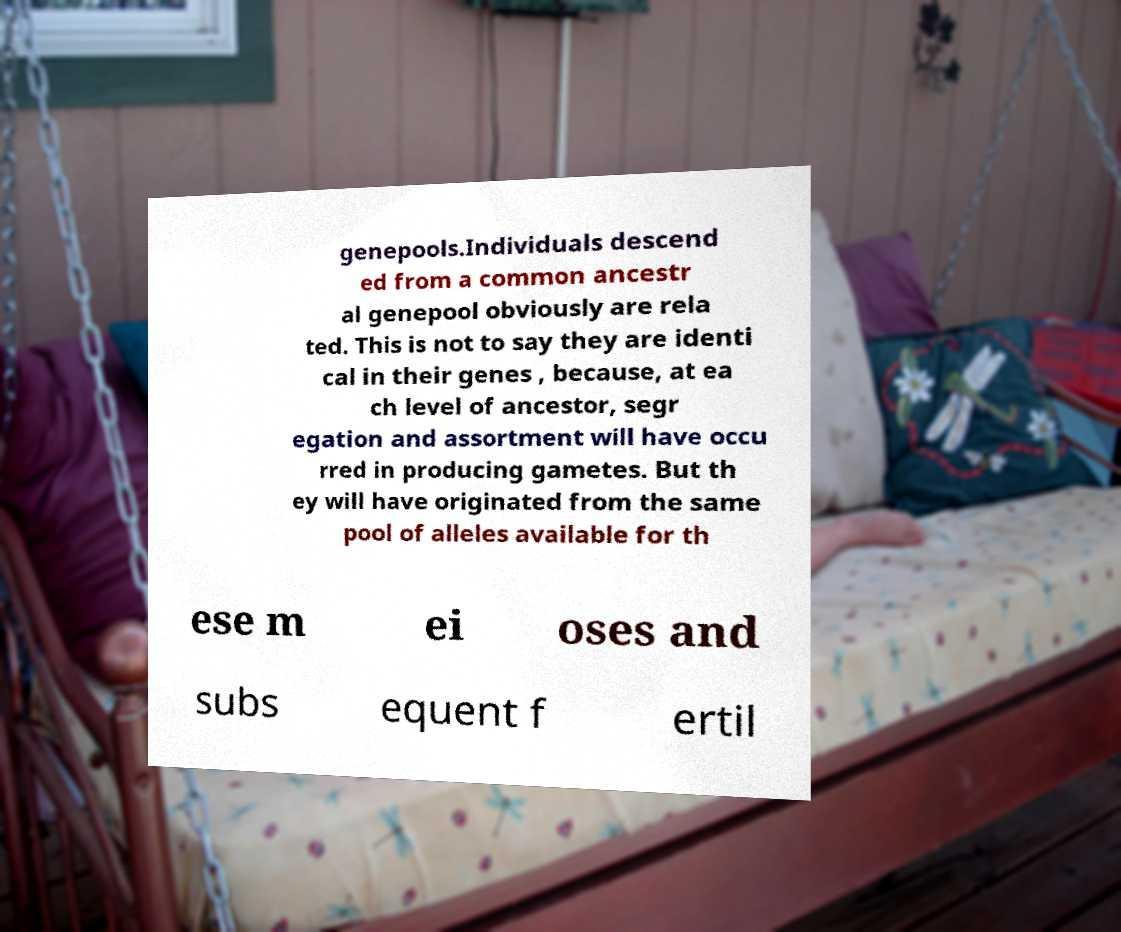Can you accurately transcribe the text from the provided image for me? genepools.Individuals descend ed from a common ancestr al genepool obviously are rela ted. This is not to say they are identi cal in their genes , because, at ea ch level of ancestor, segr egation and assortment will have occu rred in producing gametes. But th ey will have originated from the same pool of alleles available for th ese m ei oses and subs equent f ertil 